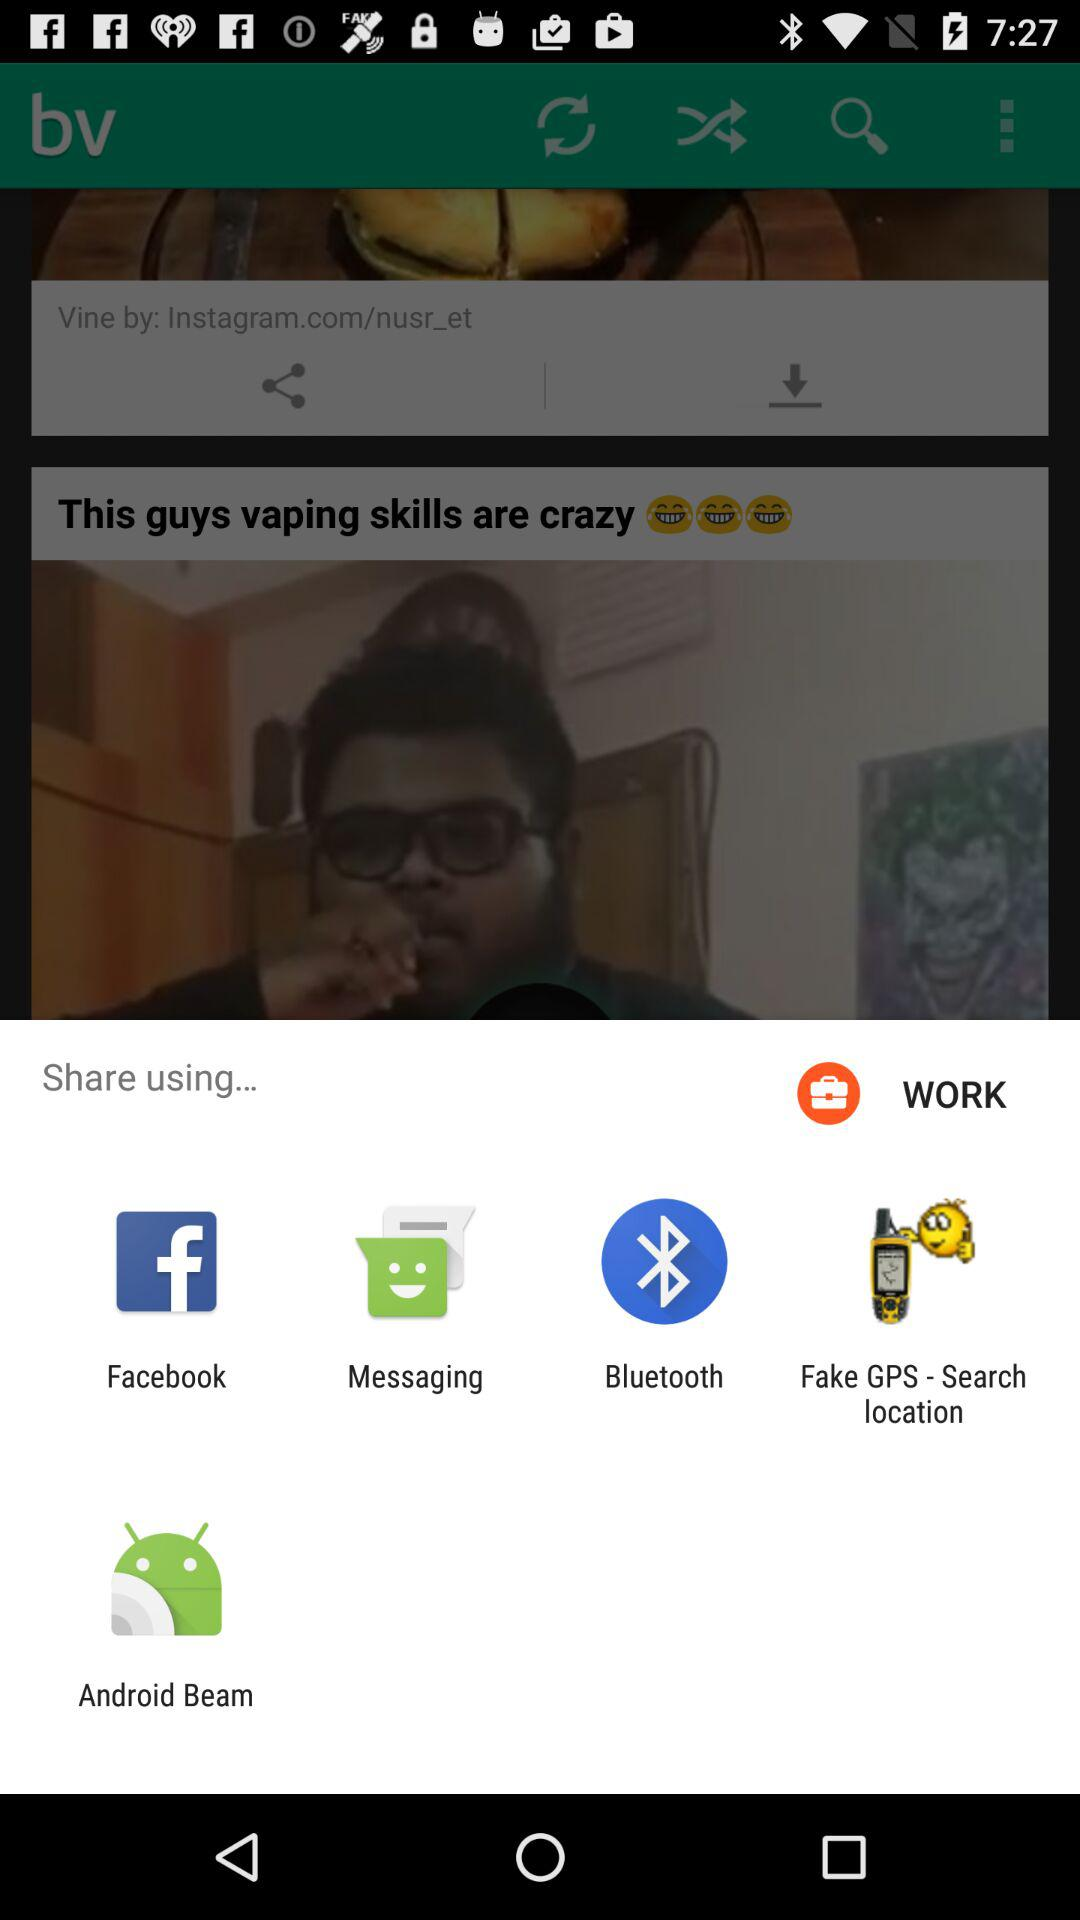Through what app can we share? You can share with "Facebook", "Messaging", "Bluetooth", "Fake GPS - Search location" and "Android Beam". 